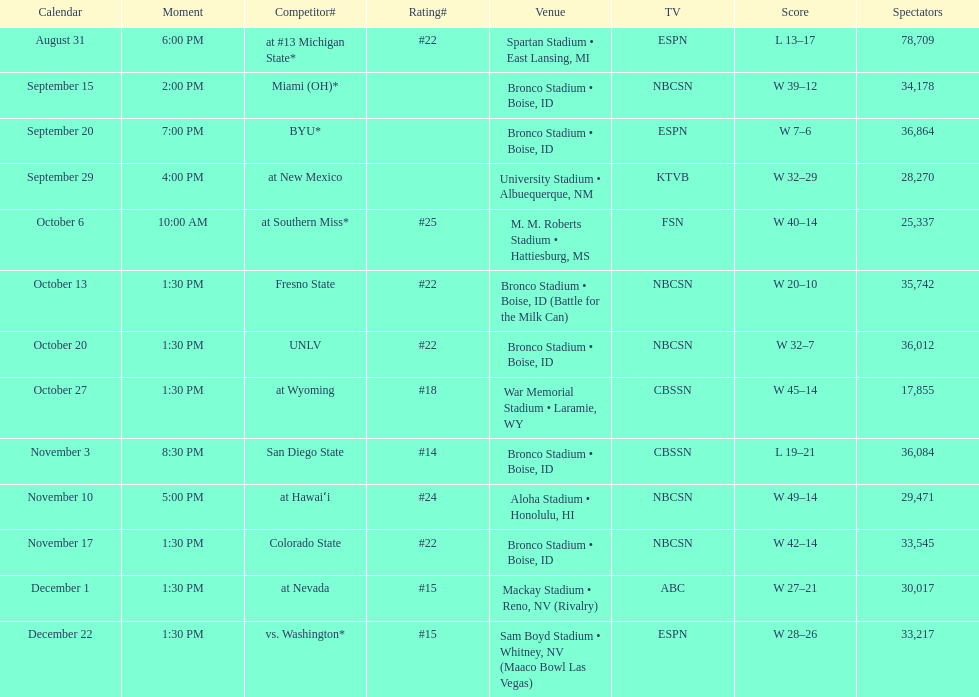What is the score difference for the game against michigan state? 4. 